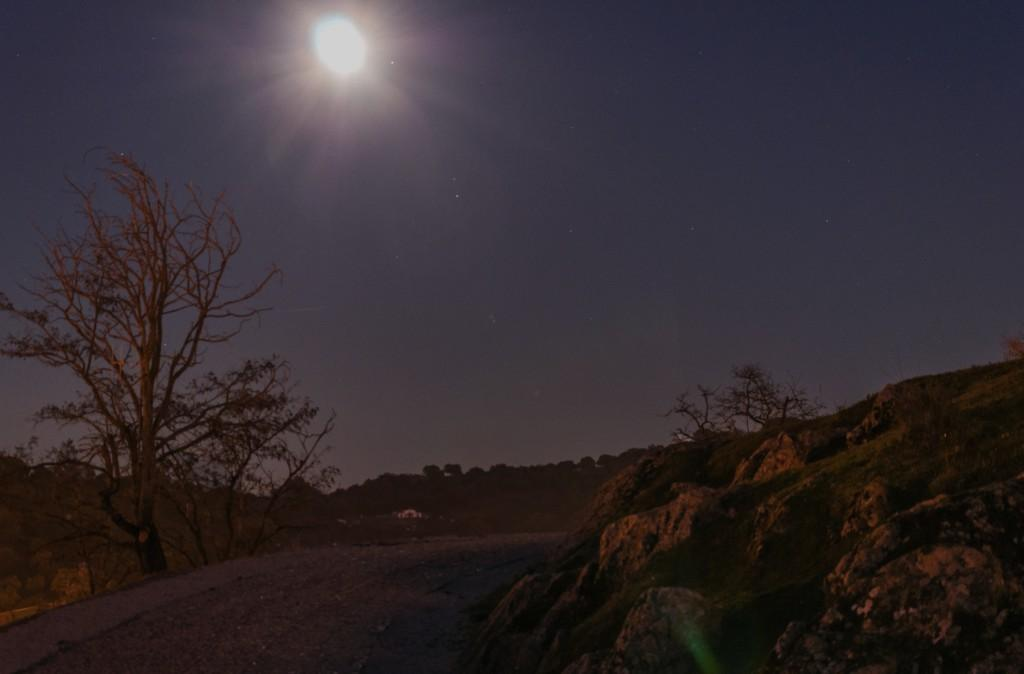What type of natural elements can be seen in the image? There are plants, trees, and rocks visible in the image. What celestial body can be seen in the image? The moon is visible in the image. What else is visible in the image besides the natural elements and the moon? The sky is visible in the image. What type of wheel can be seen attached to the plants in the image? There is no wheel present in the image, and the plants are not attached to any wheel. How many eggs are visible in the image? There are no eggs present in the image. 